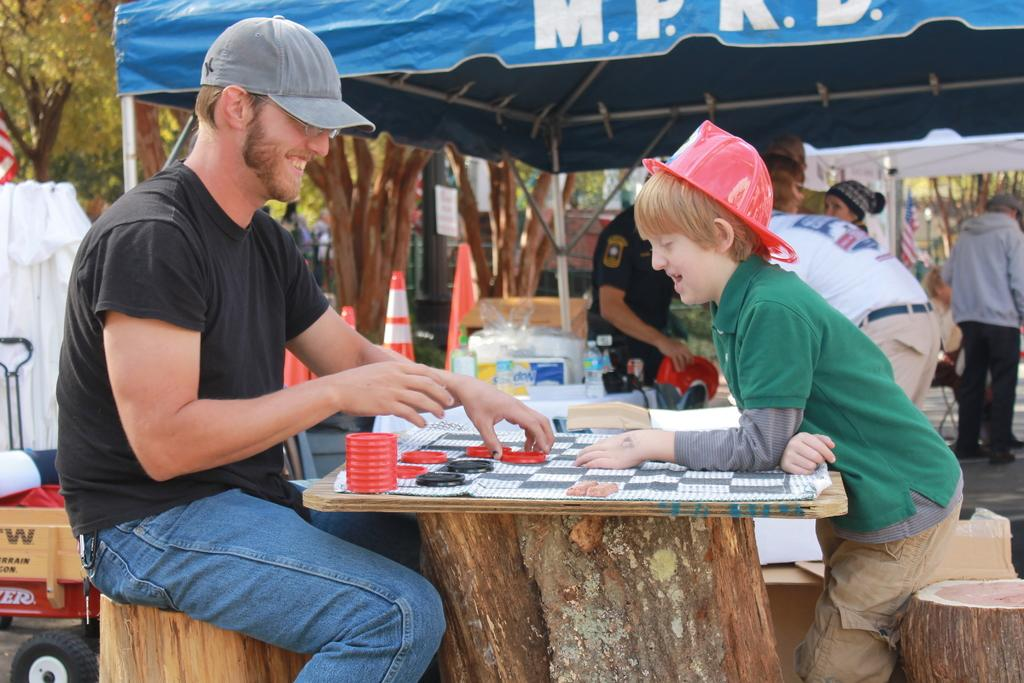Who is present in the image? There is a person and a child in the image. How are they positioned in relation to each other? The person and child are sitting opposite to each other. What activity are they engaged in? They are playing on a table. Can you describe the table in the image? The table is in front of them. What additional features can be seen in the background of the image? There are tents and trees visible in the image. What type of hat is the child wearing in the image? There is no hat visible on the child in the image. What mark does the person make on the table during their playtime? There is no mention of any mark being made on the table in the image. 